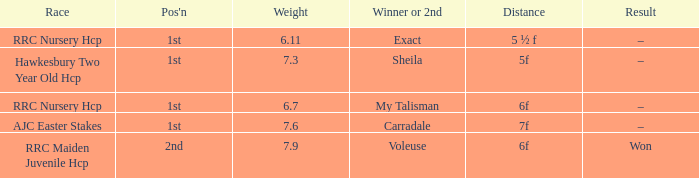Parse the full table. {'header': ['Race', "Pos'n", 'Weight', 'Winner or 2nd', 'Distance', 'Result'], 'rows': [['RRC Nursery Hcp', '1st', '6.11', 'Exact', '5 ½ f', '–'], ['Hawkesbury Two Year Old Hcp', '1st', '7.3', 'Sheila', '5f', '–'], ['RRC Nursery Hcp', '1st', '6.7', 'My Talisman', '6f', '–'], ['AJC Easter Stakes', '1st', '7.6', 'Carradale', '7f', '–'], ['RRC Maiden Juvenile Hcp', '2nd', '7.9', 'Voleuse', '6f', 'Won']]} What was the name of the winner or 2nd when the result was –, and weight was 6.7? My Talisman. 